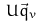<formula> <loc_0><loc_0><loc_500><loc_500>U \vec { q } _ { v }</formula> 